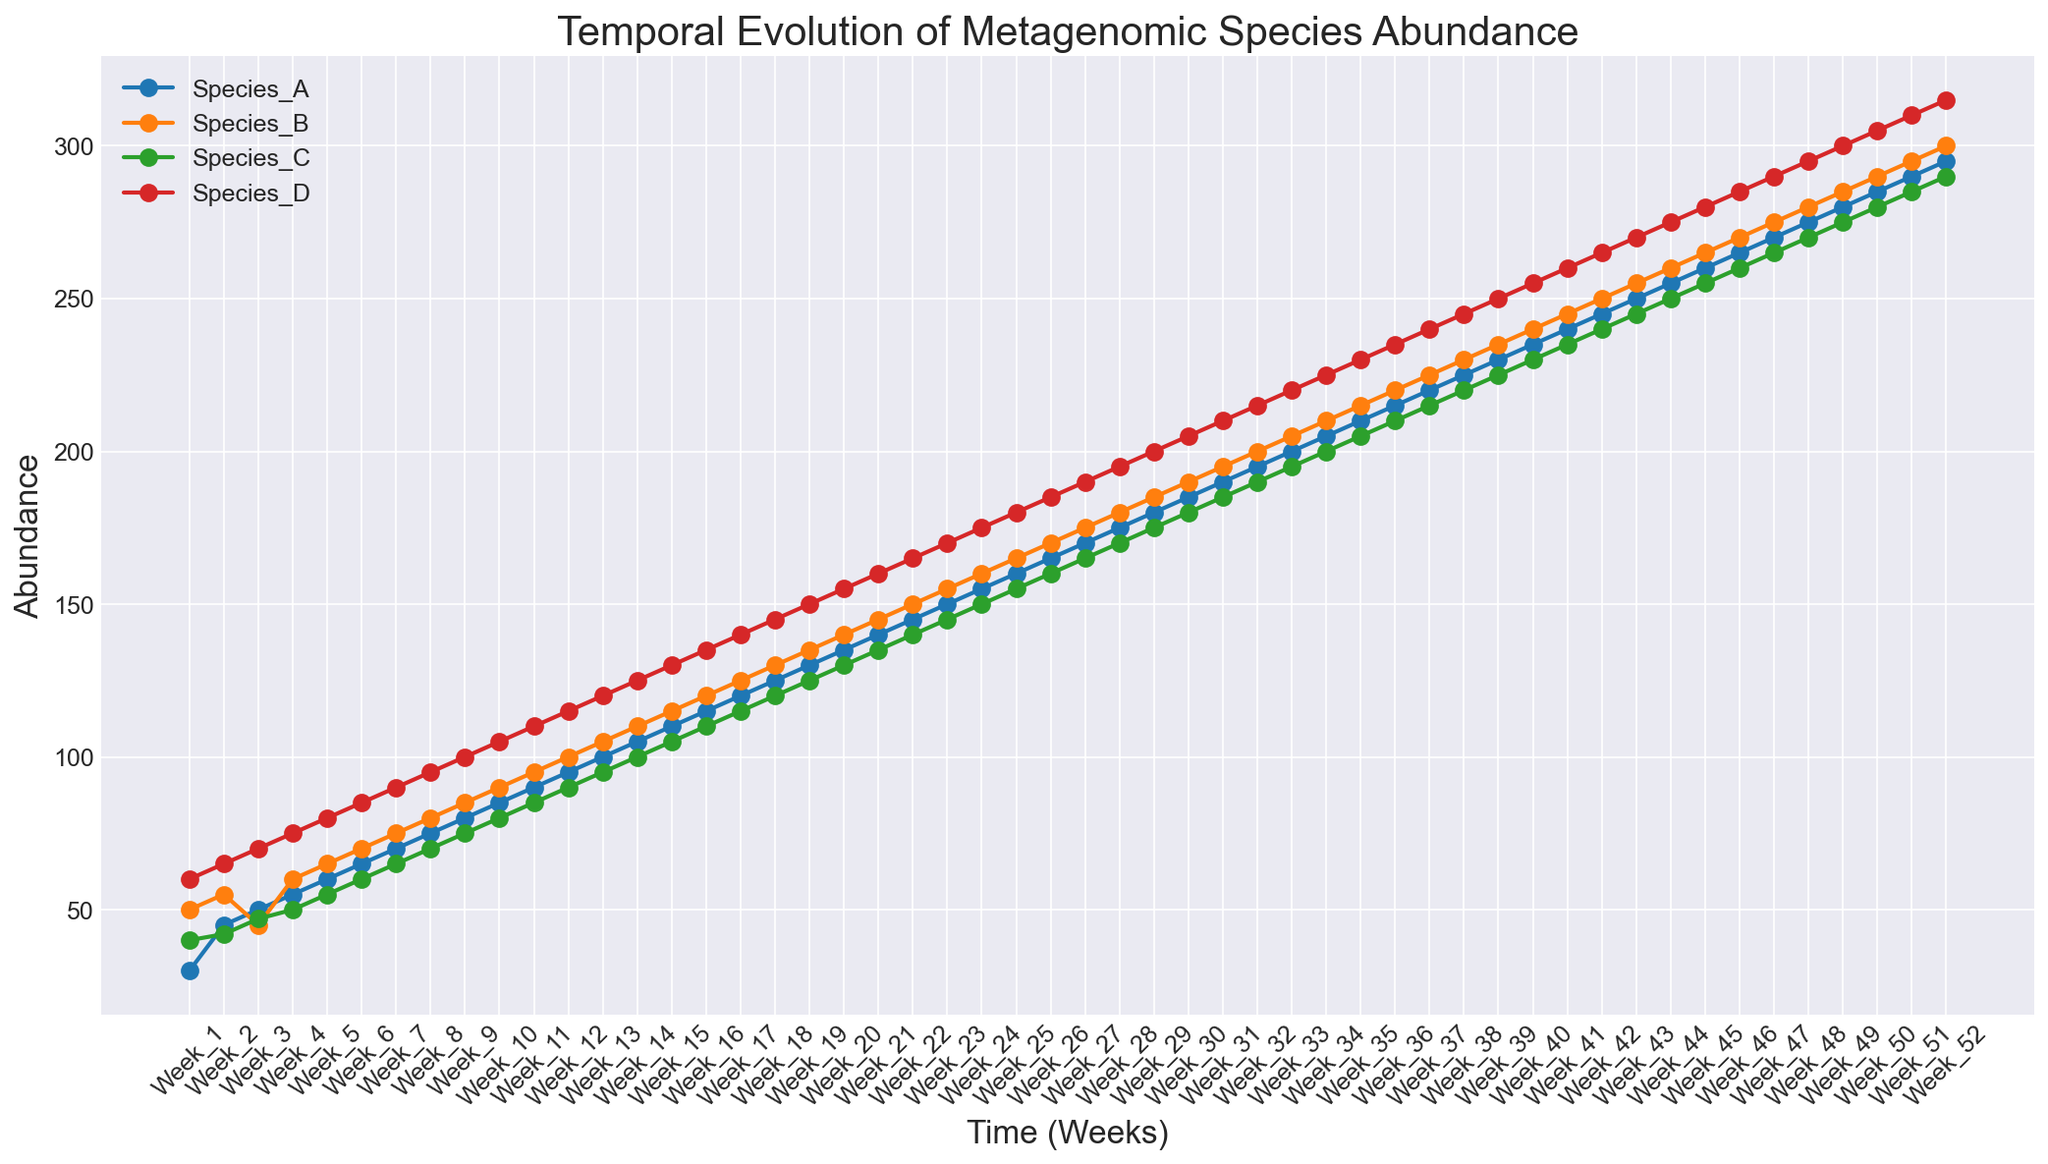What is the overall trend in the abundance of Species A over time? The line chart for Species A shows an upward trend from Week 1 to Week 52, indicating that its abundance continuously increased throughout the 52 weeks.
Answer: Upward trend At which week does Species B first reach an abundance greater than or equal to 150? To find this, look for the week on the x-axis where the line for Species B crosses the 150 mark on the y-axis. This occurs at Week 22.
Answer: Week 22 Which species has the highest abundance at Week 30? At Week 30, locate the vertical line corresponding to Week 30 on the x-axis and compare the heights of the lines for each species. Species D has the highest line at this point.
Answer: Species D Compare the rate of increase in abundance between Species C and Species D from Week 10 to Week 20. Which species shows a greater increase? Calculate the difference in abundances for both species between Week 10 and Week 20: For Species C (130 - 80 = 50) and for Species D (155 - 105 = 50). Both species show the same increase in abundance of 50.
Answer: Both equal What is the sum of the abundances of all species at Week 40? Read the abundance values for Week 40 from the chart: Species A (235), Species B (240), Species C (230), and Species D (255). Sum these values: 235 + 240 + 230 + 255 = 960.
Answer: 960 At Week 15, how much higher is the abundance of Species D compared to Species C? Find the abundances at Week 15: Species C (105) and Species D (130). Subtract to find the difference: 130 - 105 = 25.
Answer: 25 Between which two consecutive weeks does Species A show the maximum increase in abundance? Identify the week-to-week increases for Species A and find the largest value. The largest increase is from Week 51 to Week 52, where the abundance increases from 290 to 295, a difference of 5.
Answer: Week 51 to Week 52 What is the average abundance of Species B across all 52 weeks? Sum the abundances of Species B for all weeks and divide by 52. The total sum is calculated as the sum of the arithmetic series (50 to 300 with a common difference of 5), which equals 9100. The average is 9100 / 52 = approximately 175.
Answer: 175 What is the color representation of Species C in the plot? Examine the legend in the plot to identify the color used for Species C. In the provided code, each species would be represented by a distinct color, which can be identified visually.
Answer: Color as per legend Does any species show a decline in abundance at any point during the 52 weeks? Check each species' line from Week 1 to Week 52 to identify any downward trend. All species lines continually rise, showing no decline at any point.
Answer: No 